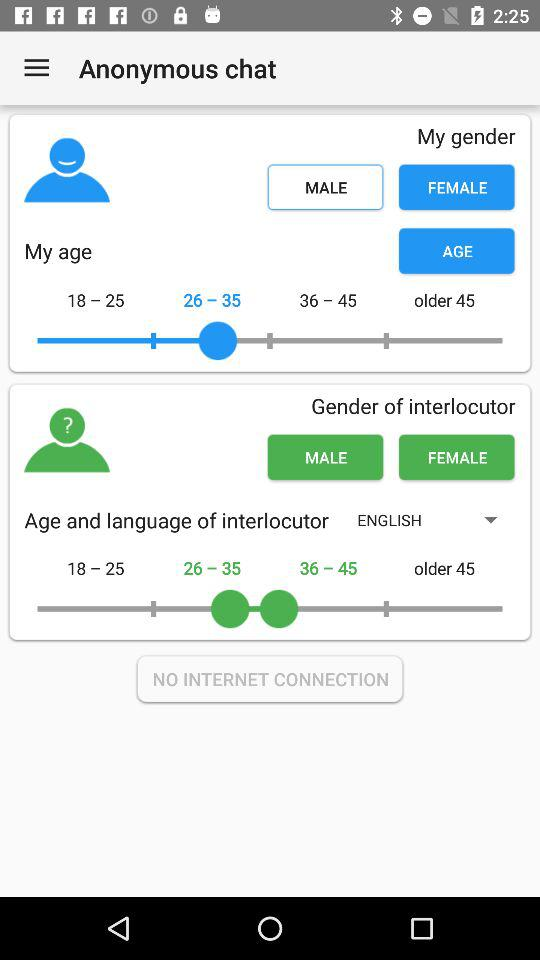What is the selected age in "My age"? The selected age in "My age" is 26-35. 